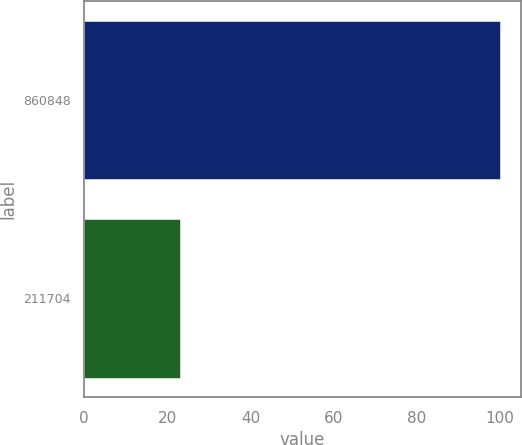<chart> <loc_0><loc_0><loc_500><loc_500><bar_chart><fcel>860848<fcel>211704<nl><fcel>100<fcel>23<nl></chart> 